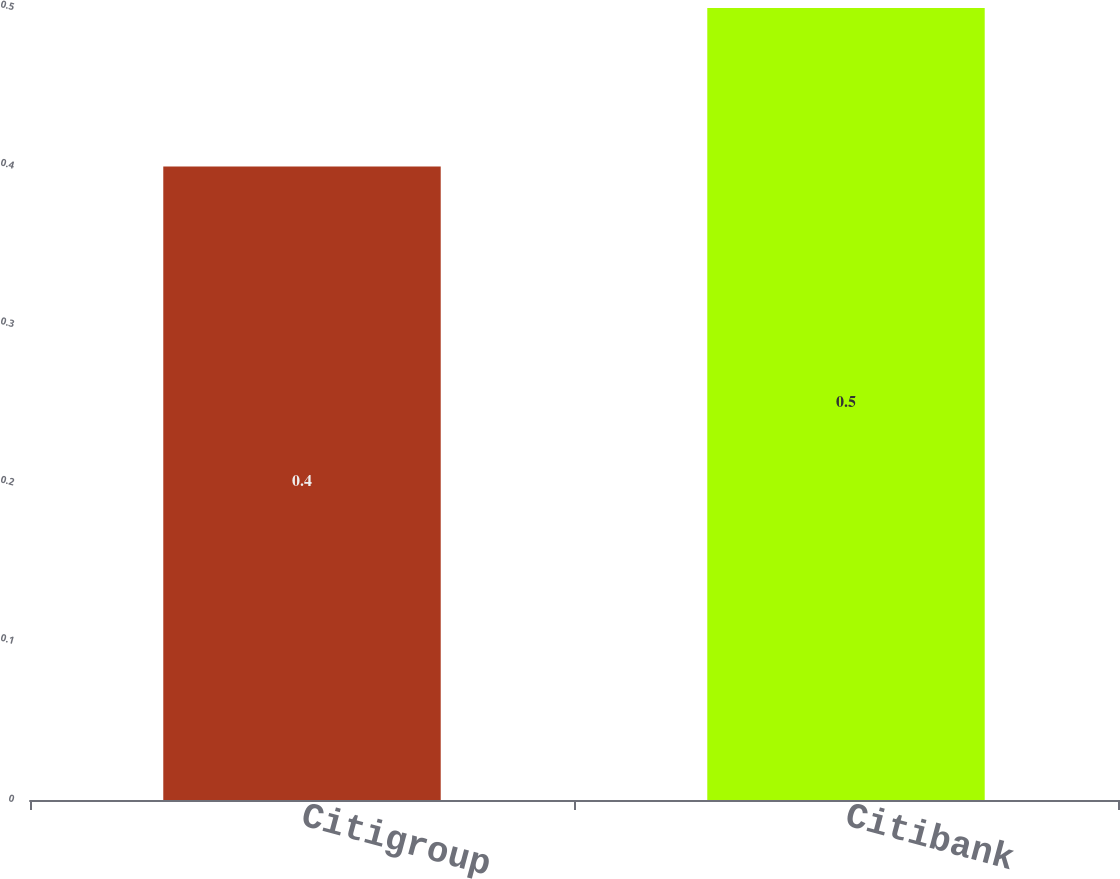Convert chart to OTSL. <chart><loc_0><loc_0><loc_500><loc_500><bar_chart><fcel>Citigroup<fcel>Citibank<nl><fcel>0.4<fcel>0.5<nl></chart> 